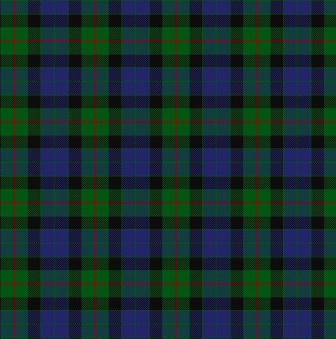I need a detailed analysis of this tartan pattern. Certainly! The image features a digitally rendered tartan plaid design with a meticulous grid-like pattern. The design comprises horizontal and vertical lines intersecting to form squares and rectangles, arranged in a repetitive sequence. The primary colors used are green, blue, black, and red, each filling specific segments of the grid. These color blocks create a visually striking pattern where the intersections and overlapping areas add depth and intricacy. Tartan patterns like this one are traditionally used in textiles to represent clans or regions. This digital representation offers clean, sharp lines, and vibrant colors that highlight the precision and symmetry of the design. 